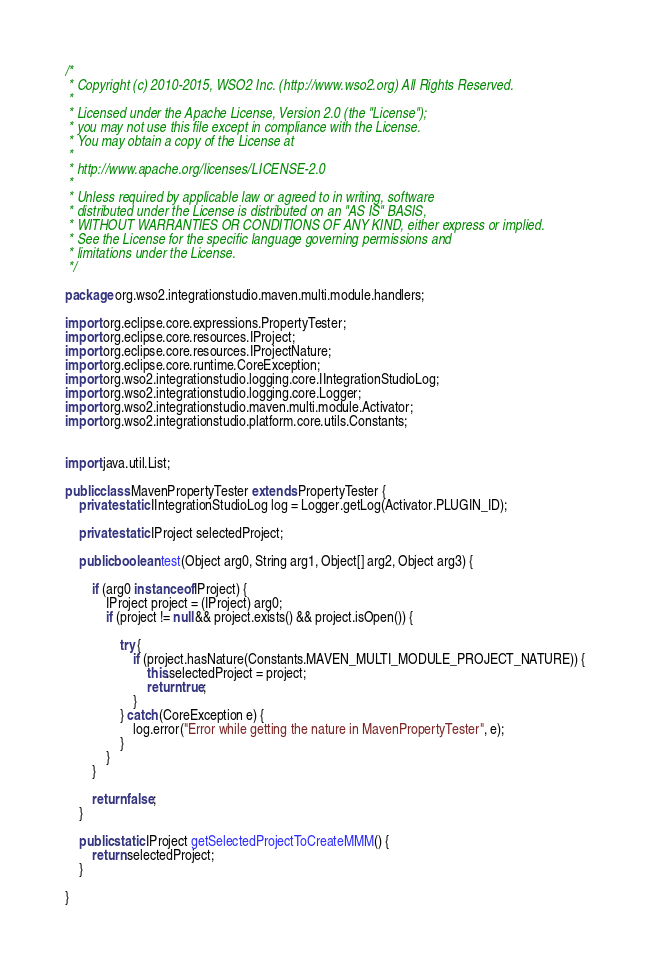<code> <loc_0><loc_0><loc_500><loc_500><_Java_>/*
 * Copyright (c) 2010-2015, WSO2 Inc. (http://www.wso2.org) All Rights Reserved.
 * 
 * Licensed under the Apache License, Version 2.0 (the "License");
 * you may not use this file except in compliance with the License.
 * You may obtain a copy of the License at
 * 
 * http://www.apache.org/licenses/LICENSE-2.0
 * 
 * Unless required by applicable law or agreed to in writing, software
 * distributed under the License is distributed on an "AS IS" BASIS,
 * WITHOUT WARRANTIES OR CONDITIONS OF ANY KIND, either express or implied.
 * See the License for the specific language governing permissions and
 * limitations under the License.
 */

package org.wso2.integrationstudio.maven.multi.module.handlers;

import org.eclipse.core.expressions.PropertyTester;
import org.eclipse.core.resources.IProject;
import org.eclipse.core.resources.IProjectNature;
import org.eclipse.core.runtime.CoreException;
import org.wso2.integrationstudio.logging.core.IIntegrationStudioLog;
import org.wso2.integrationstudio.logging.core.Logger;
import org.wso2.integrationstudio.maven.multi.module.Activator;
import org.wso2.integrationstudio.platform.core.utils.Constants;


import java.util.List;

public class MavenPropertyTester extends PropertyTester {
	private static IIntegrationStudioLog log = Logger.getLog(Activator.PLUGIN_ID);
	
	private static IProject selectedProject;

	public boolean test(Object arg0, String arg1, Object[] arg2, Object arg3) {

		if (arg0 instanceof IProject) {
			IProject project = (IProject) arg0;
			if (project != null && project.exists() && project.isOpen()) {

				try {
					if (project.hasNature(Constants.MAVEN_MULTI_MODULE_PROJECT_NATURE)) {
					    this.selectedProject = project;
						return true;
					}
				} catch (CoreException e) {
					log.error("Error while getting the nature in MavenPropertyTester", e);
				}
			}
		}

		return false;
	}
	
	public static IProject getSelectedProjectToCreateMMM() {
        return selectedProject;
    }

}
</code> 